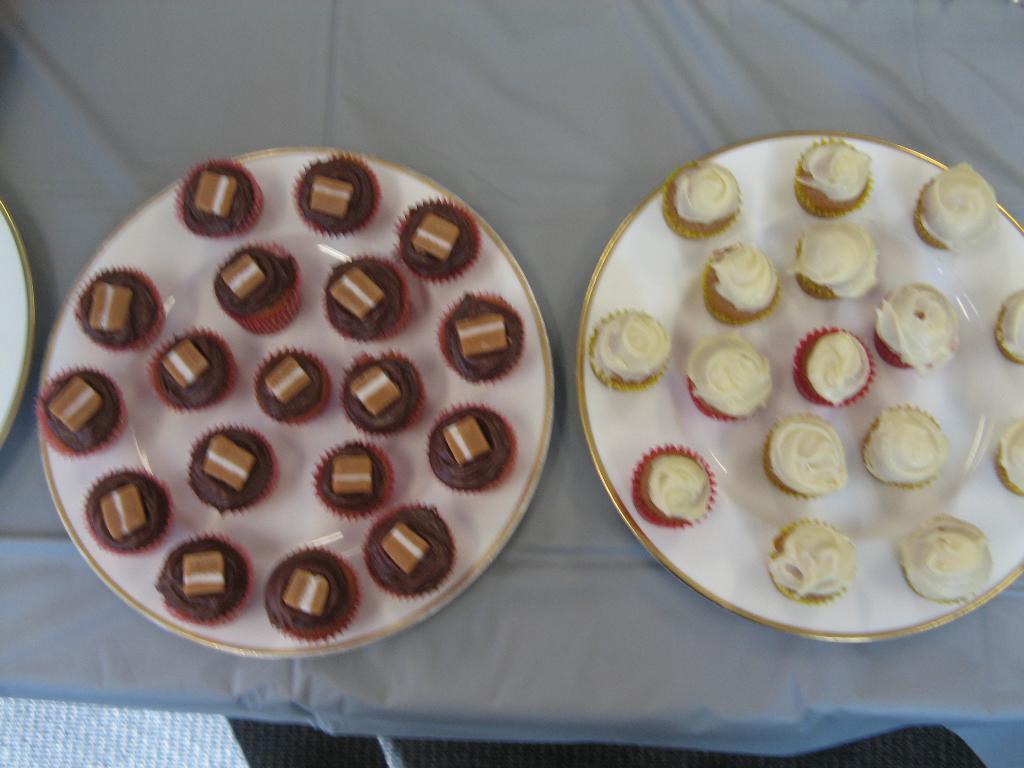Describe this image in one or two sentences. In this image I can see there are few cup cakes kept on two plates and two plates might be kept on table. 